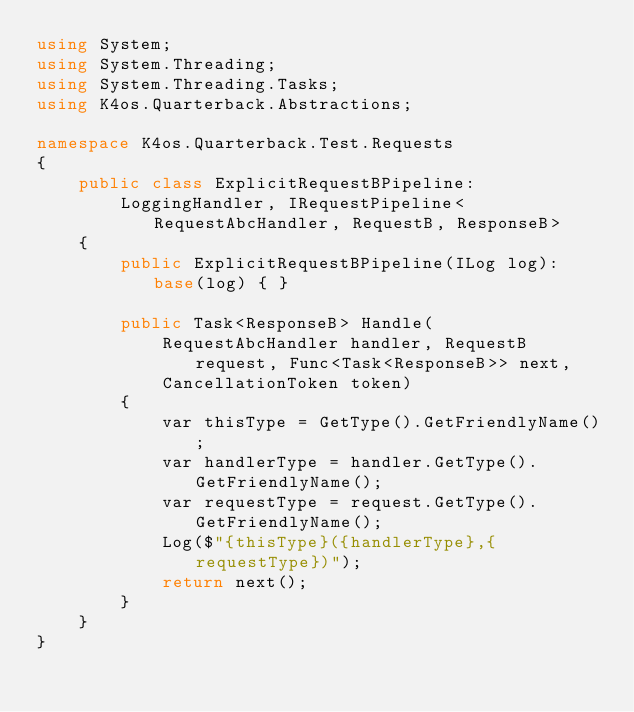Convert code to text. <code><loc_0><loc_0><loc_500><loc_500><_C#_>using System;
using System.Threading;
using System.Threading.Tasks;
using K4os.Quarterback.Abstractions;

namespace K4os.Quarterback.Test.Requests
{
	public class ExplicitRequestBPipeline:
		LoggingHandler, IRequestPipeline<RequestAbcHandler, RequestB, ResponseB>
	{
		public ExplicitRequestBPipeline(ILog log): base(log) { }

		public Task<ResponseB> Handle(
			RequestAbcHandler handler, RequestB request, Func<Task<ResponseB>> next,
			CancellationToken token)
		{
			var thisType = GetType().GetFriendlyName();
			var handlerType = handler.GetType().GetFriendlyName();
			var requestType = request.GetType().GetFriendlyName();
			Log($"{thisType}({handlerType},{requestType})");
			return next();
		}
	}
}
</code> 